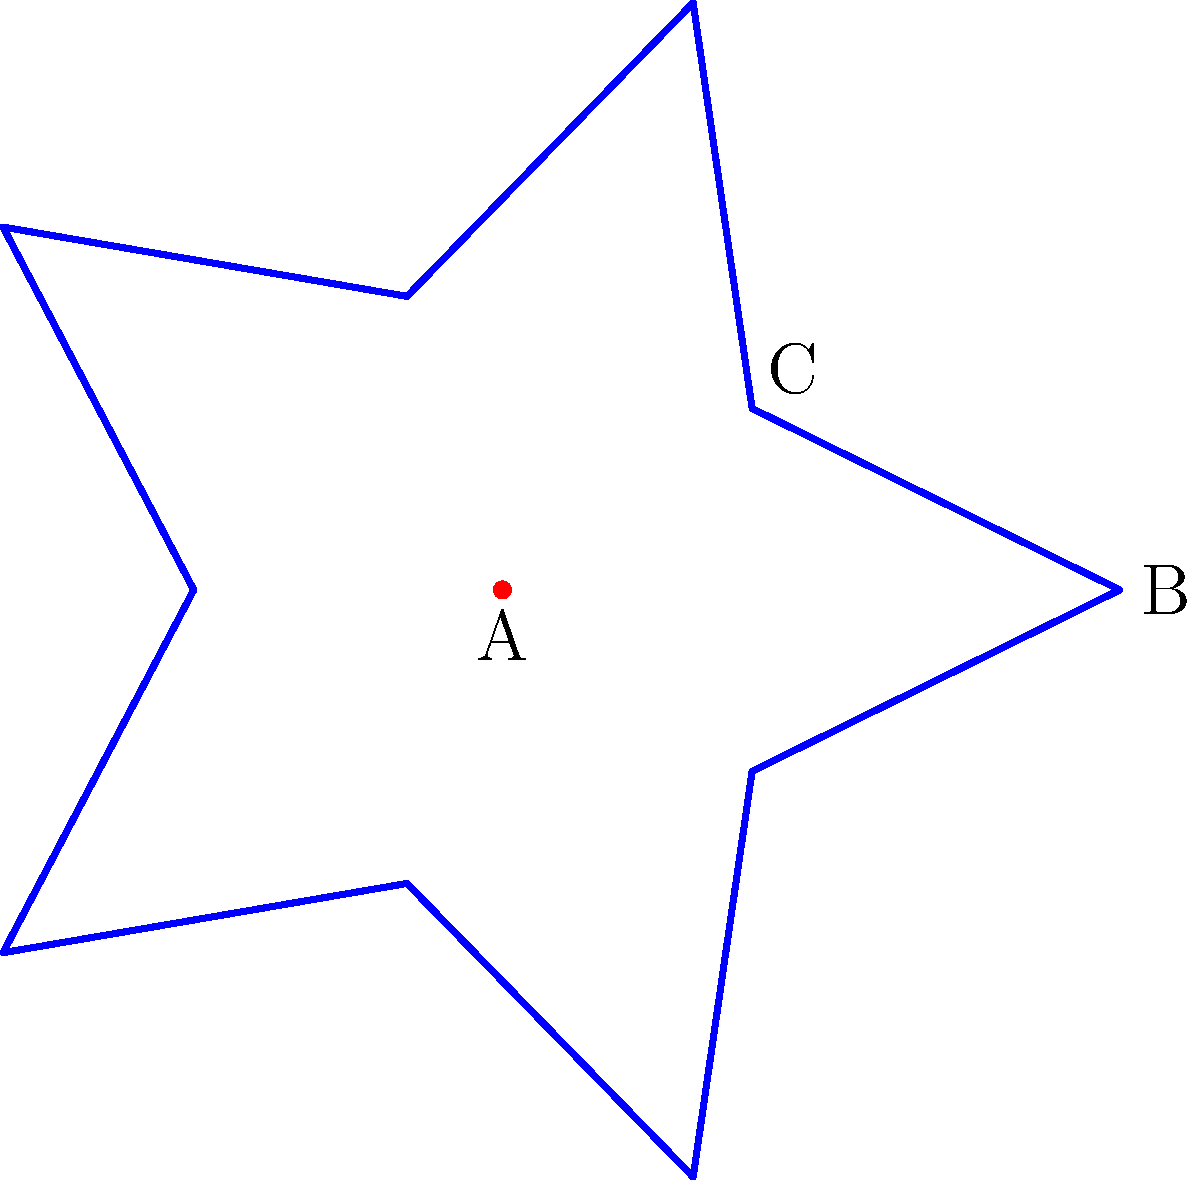You want to create a star-shaped cookie cutter for your elderly client who loves festive treats. The star should have 5 points and be symmetrical. If point A is the center of the star, B is the outermost point, and C is the innermost point between two outer points, what is the measure of angle BAC to ensure the star is symmetrical? To find the measure of angle BAC for a symmetrical 5-pointed star, we can follow these steps:

1) In a regular 5-pointed star, the angle between each arm is $\frac{360°}{5} = 72°$.

2) The angle we're looking for (BAC) is half of this angle, as it goes from the center to the outer point.

3) Therefore, the angle BAC is:

   $$\text{Angle BAC} = \frac{72°}{2} = 36°$$

4) We can verify this by noting that in a symmetrical 5-pointed star:
   - The full circle (360°) is divided into 10 equal parts (5 outer points and 5 inner points).
   - Each of these parts is $\frac{360°}{10} = 36°$.

5) This angle ensures that the star is symmetrical, as it creates equal spacing between all points of the star when rotated around the center.
Answer: 36° 